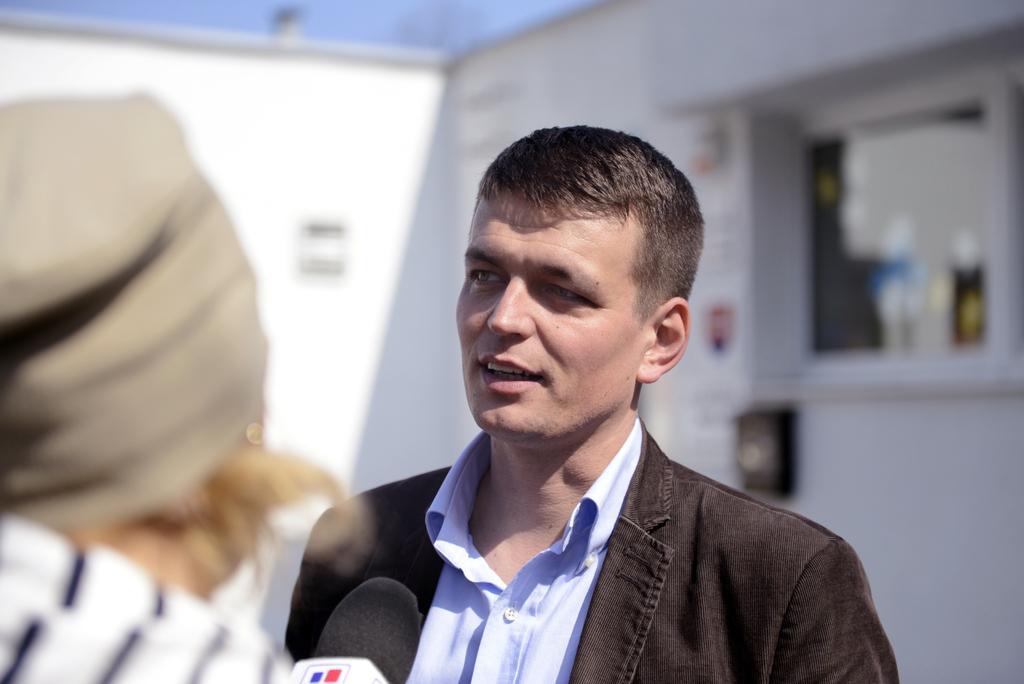Could you give a brief overview of what you see in this image? In this picture, we can see two persons and we can find a microphone, we can see the blurred background. 